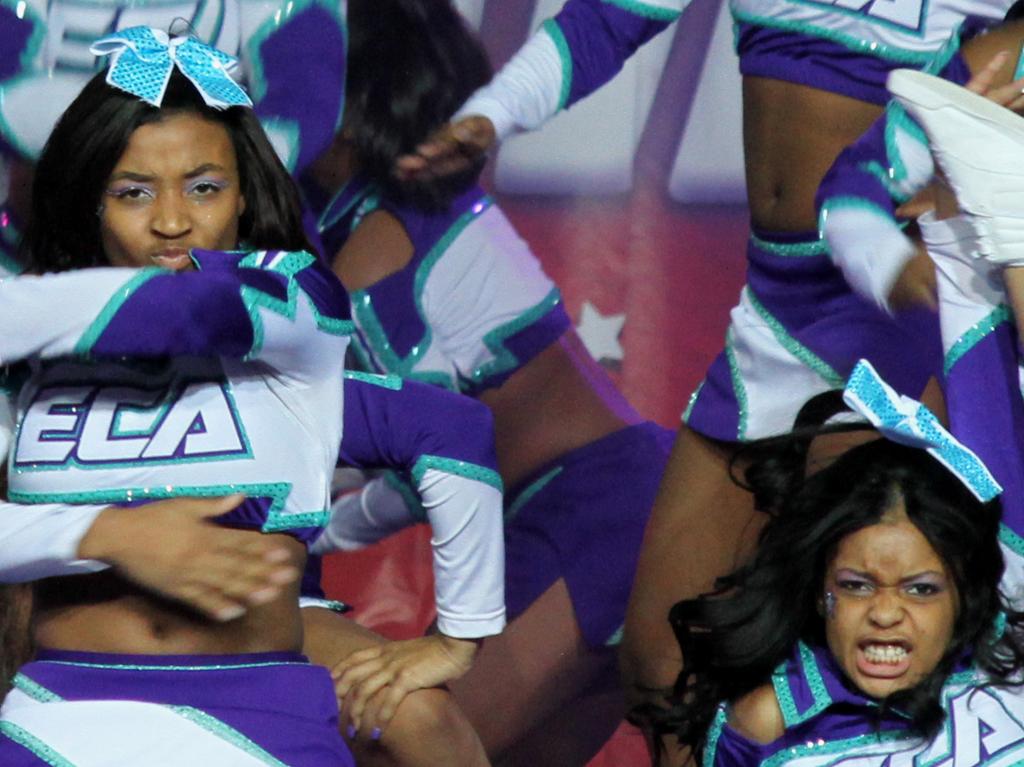What three letters on on this girls shirt?
Your answer should be very brief. Eca. 